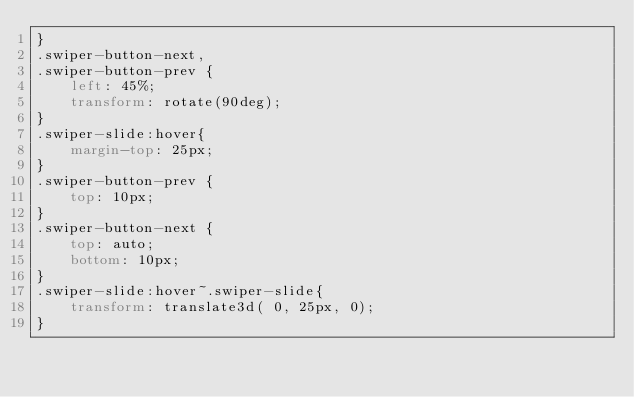<code> <loc_0><loc_0><loc_500><loc_500><_CSS_>}
.swiper-button-next,
.swiper-button-prev {
    left: 45%;
    transform: rotate(90deg);
}
.swiper-slide:hover{
    margin-top: 25px;
}
.swiper-button-prev {
    top: 10px;
}
.swiper-button-next {
    top: auto;
    bottom: 10px;
}
.swiper-slide:hover~.swiper-slide{
    transform: translate3d( 0, 25px, 0);
}</code> 